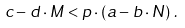<formula> <loc_0><loc_0><loc_500><loc_500>c - d \cdot M < p \cdot \left ( a - b \cdot N \right ) \, .</formula> 